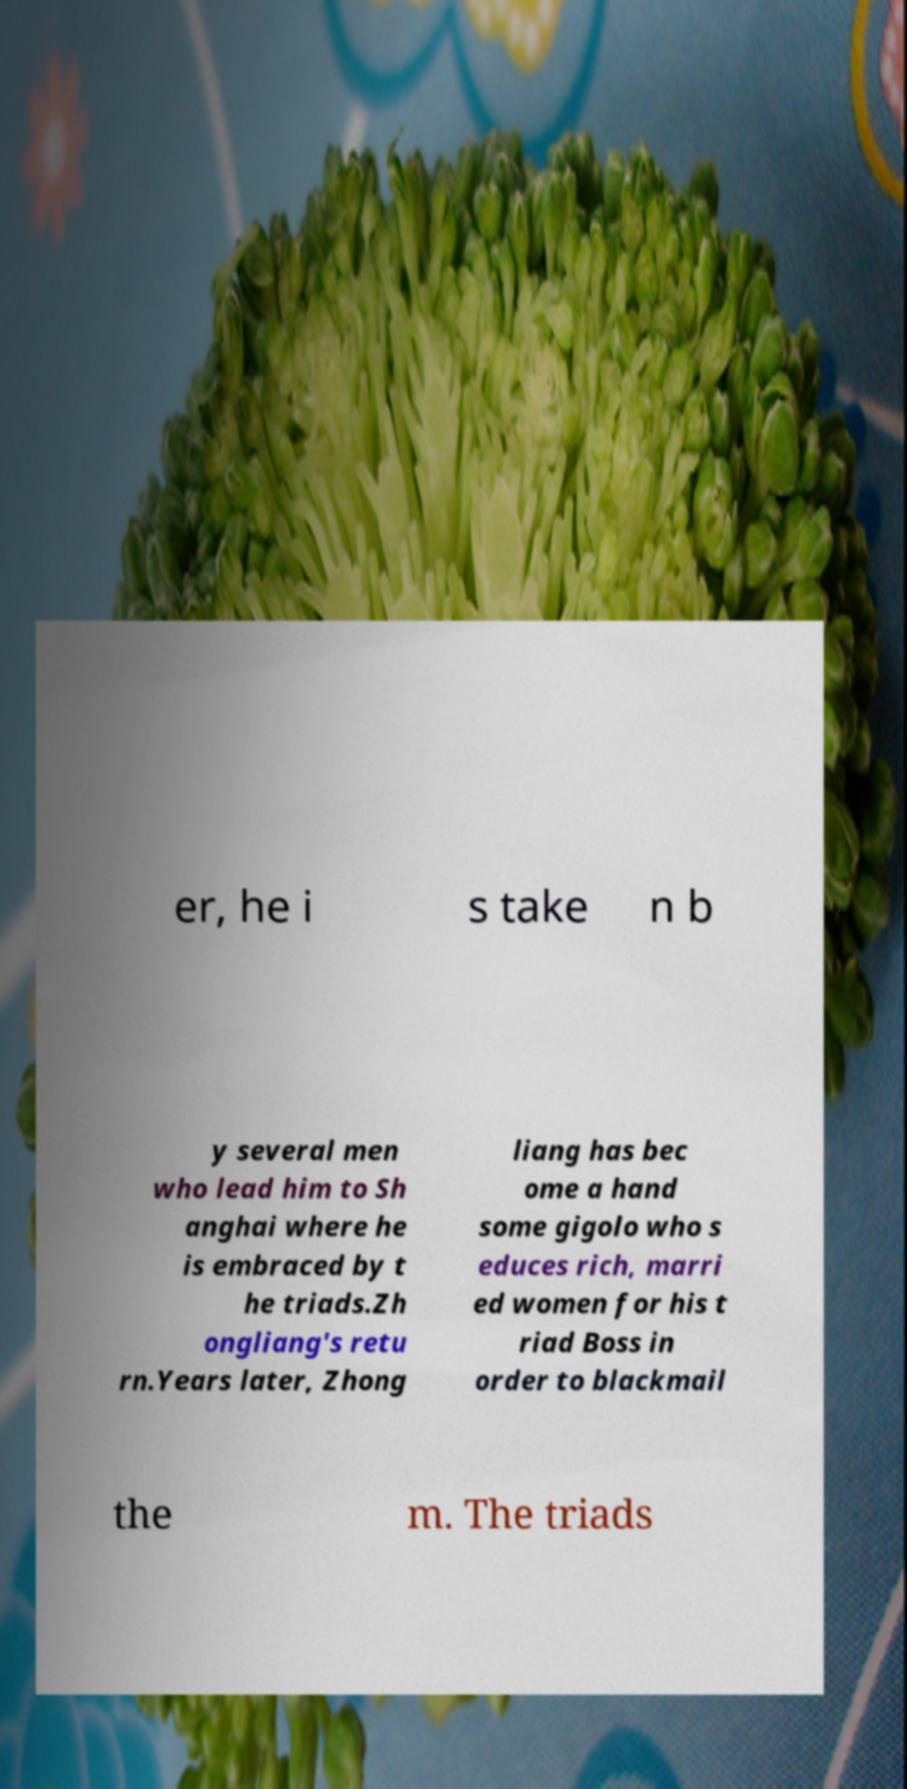Could you assist in decoding the text presented in this image and type it out clearly? er, he i s take n b y several men who lead him to Sh anghai where he is embraced by t he triads.Zh ongliang's retu rn.Years later, Zhong liang has bec ome a hand some gigolo who s educes rich, marri ed women for his t riad Boss in order to blackmail the m. The triads 